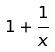<formula> <loc_0><loc_0><loc_500><loc_500>1 + \frac { 1 } { x }</formula> 